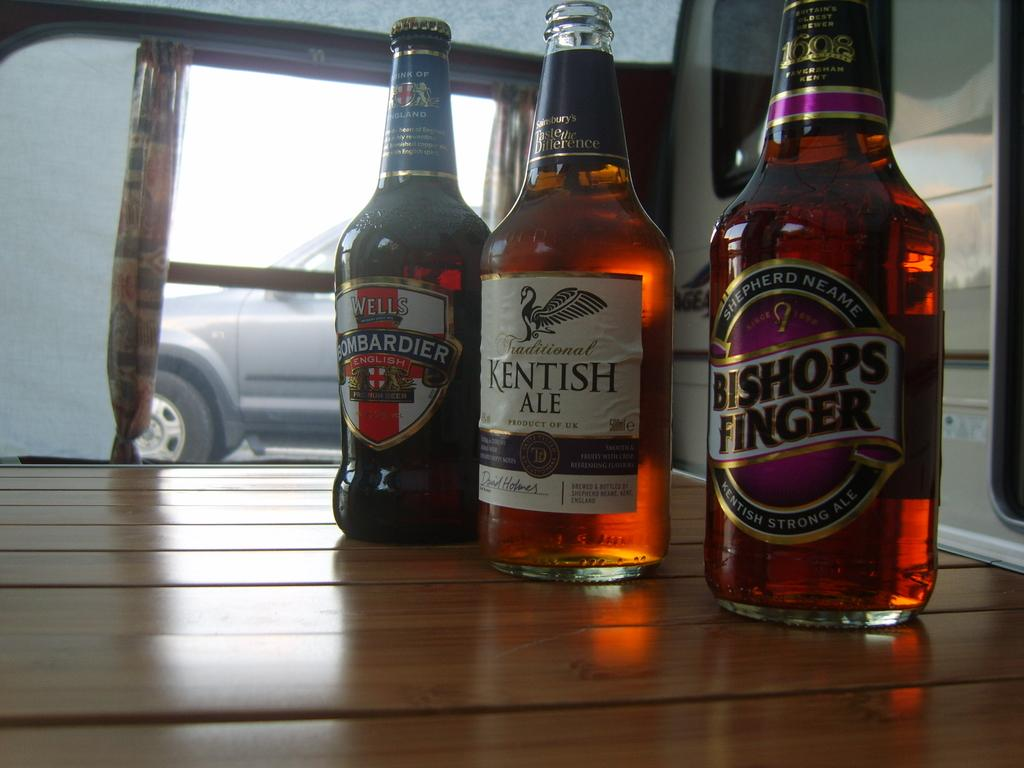How many bottles are visible in the image? There are three bottles in the image. What can be found on the bottles? The bottles have labels. What information is provided on the labels? The labels contain text. What is located on the left side of the image? There is a car on the left side of the image. What type of silver substance can be seen on the car in the image? There is no silver substance visible on the car in the image. How many frogs are sitting on the bottles in the image? There are no frogs present in the image. 